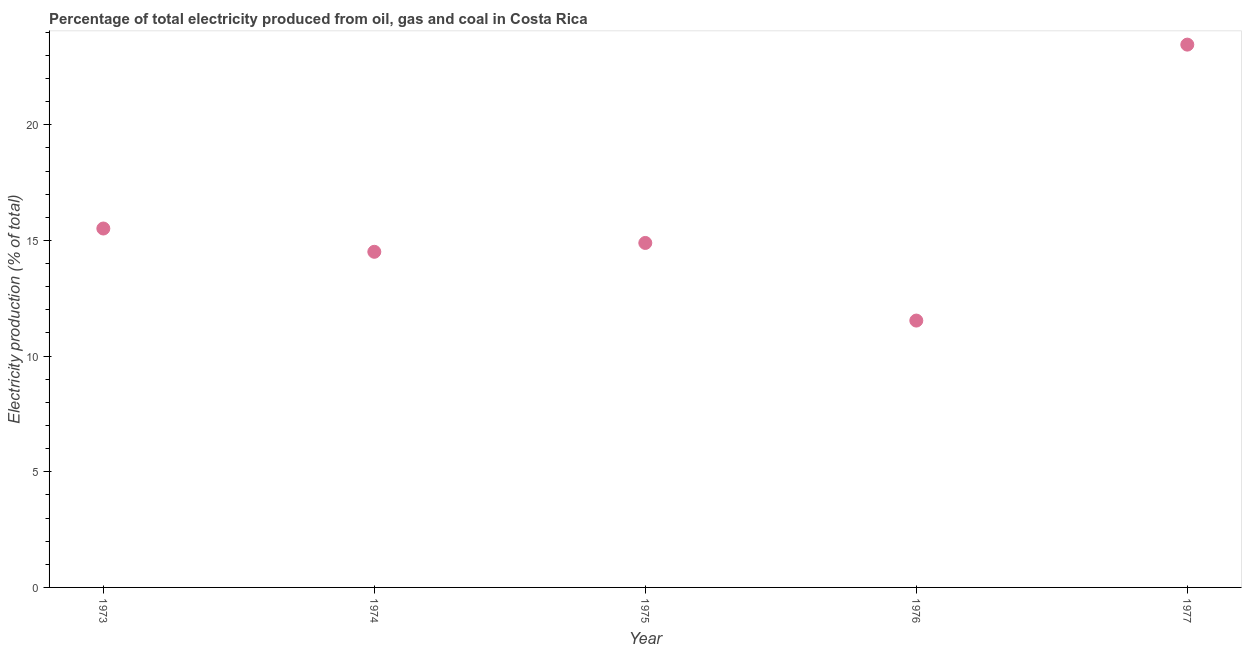What is the electricity production in 1976?
Ensure brevity in your answer.  11.54. Across all years, what is the maximum electricity production?
Keep it short and to the point. 23.47. Across all years, what is the minimum electricity production?
Your answer should be compact. 11.54. In which year was the electricity production maximum?
Offer a very short reply. 1977. In which year was the electricity production minimum?
Your answer should be very brief. 1976. What is the sum of the electricity production?
Give a very brief answer. 79.92. What is the difference between the electricity production in 1976 and 1977?
Provide a succinct answer. -11.93. What is the average electricity production per year?
Provide a succinct answer. 15.98. What is the median electricity production?
Provide a succinct answer. 14.89. In how many years, is the electricity production greater than 18 %?
Offer a terse response. 1. Do a majority of the years between 1975 and 1977 (inclusive) have electricity production greater than 10 %?
Ensure brevity in your answer.  Yes. What is the ratio of the electricity production in 1976 to that in 1977?
Keep it short and to the point. 0.49. Is the electricity production in 1976 less than that in 1977?
Provide a short and direct response. Yes. Is the difference between the electricity production in 1974 and 1977 greater than the difference between any two years?
Your answer should be very brief. No. What is the difference between the highest and the second highest electricity production?
Provide a succinct answer. 7.95. Is the sum of the electricity production in 1973 and 1975 greater than the maximum electricity production across all years?
Provide a succinct answer. Yes. What is the difference between the highest and the lowest electricity production?
Offer a terse response. 11.93. Does the electricity production monotonically increase over the years?
Provide a short and direct response. No. How many years are there in the graph?
Provide a short and direct response. 5. Does the graph contain any zero values?
Give a very brief answer. No. Does the graph contain grids?
Provide a succinct answer. No. What is the title of the graph?
Your answer should be very brief. Percentage of total electricity produced from oil, gas and coal in Costa Rica. What is the label or title of the X-axis?
Keep it short and to the point. Year. What is the label or title of the Y-axis?
Offer a very short reply. Electricity production (% of total). What is the Electricity production (% of total) in 1973?
Make the answer very short. 15.52. What is the Electricity production (% of total) in 1974?
Provide a succinct answer. 14.51. What is the Electricity production (% of total) in 1975?
Your answer should be very brief. 14.89. What is the Electricity production (% of total) in 1976?
Your answer should be compact. 11.54. What is the Electricity production (% of total) in 1977?
Keep it short and to the point. 23.47. What is the difference between the Electricity production (% of total) in 1973 and 1974?
Offer a terse response. 1.01. What is the difference between the Electricity production (% of total) in 1973 and 1975?
Give a very brief answer. 0.62. What is the difference between the Electricity production (% of total) in 1973 and 1976?
Give a very brief answer. 3.98. What is the difference between the Electricity production (% of total) in 1973 and 1977?
Your response must be concise. -7.95. What is the difference between the Electricity production (% of total) in 1974 and 1975?
Provide a succinct answer. -0.38. What is the difference between the Electricity production (% of total) in 1974 and 1976?
Provide a short and direct response. 2.97. What is the difference between the Electricity production (% of total) in 1974 and 1977?
Provide a short and direct response. -8.96. What is the difference between the Electricity production (% of total) in 1975 and 1976?
Offer a terse response. 3.36. What is the difference between the Electricity production (% of total) in 1975 and 1977?
Provide a short and direct response. -8.57. What is the difference between the Electricity production (% of total) in 1976 and 1977?
Keep it short and to the point. -11.93. What is the ratio of the Electricity production (% of total) in 1973 to that in 1974?
Offer a very short reply. 1.07. What is the ratio of the Electricity production (% of total) in 1973 to that in 1975?
Provide a short and direct response. 1.04. What is the ratio of the Electricity production (% of total) in 1973 to that in 1976?
Your response must be concise. 1.34. What is the ratio of the Electricity production (% of total) in 1973 to that in 1977?
Give a very brief answer. 0.66. What is the ratio of the Electricity production (% of total) in 1974 to that in 1976?
Offer a terse response. 1.26. What is the ratio of the Electricity production (% of total) in 1974 to that in 1977?
Ensure brevity in your answer.  0.62. What is the ratio of the Electricity production (% of total) in 1975 to that in 1976?
Offer a terse response. 1.29. What is the ratio of the Electricity production (% of total) in 1975 to that in 1977?
Ensure brevity in your answer.  0.64. What is the ratio of the Electricity production (% of total) in 1976 to that in 1977?
Your answer should be compact. 0.49. 